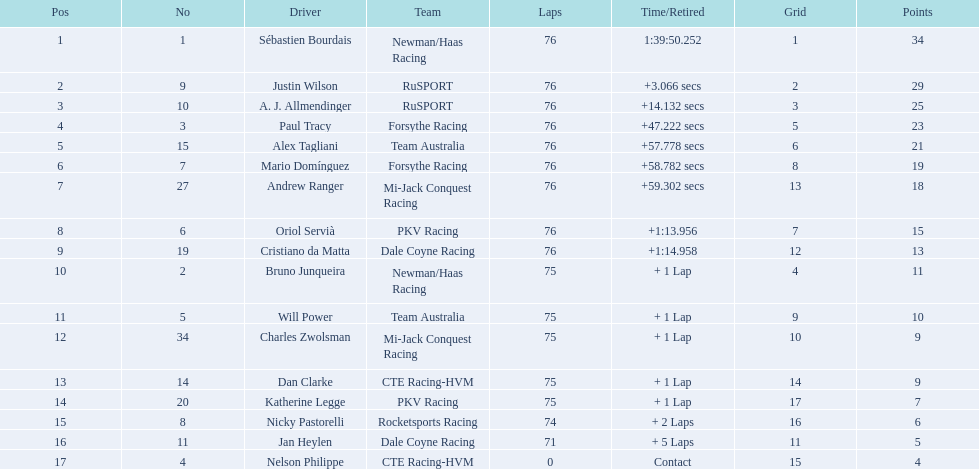Which drivers finished all 76 laps? Sébastien Bourdais, Justin Wilson, A. J. Allmendinger, Paul Tracy, Alex Tagliani, Mario Domínguez, Andrew Ranger, Oriol Servià, Cristiano da Matta. Among them, who finished within a minute of the first-place driver? Paul Tracy, Alex Tagliani, Mario Domínguez, Andrew Ranger. From this group, who finished within 50 seconds of the first place? Justin Wilson, A. J. Allmendinger, Paul Tracy. Finally, who came in last among these three drivers? Paul Tracy. 